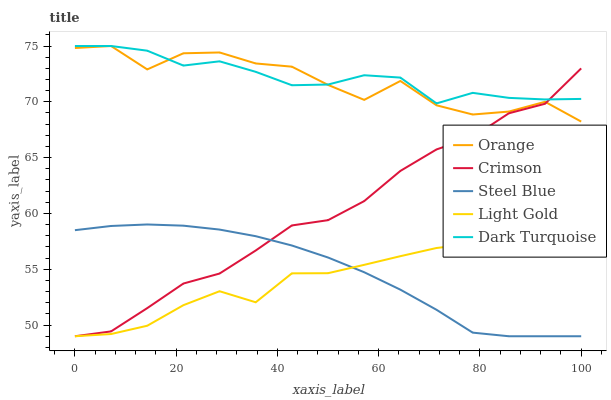Does Light Gold have the minimum area under the curve?
Answer yes or no. Yes. Does Dark Turquoise have the maximum area under the curve?
Answer yes or no. Yes. Does Crimson have the minimum area under the curve?
Answer yes or no. No. Does Crimson have the maximum area under the curve?
Answer yes or no. No. Is Steel Blue the smoothest?
Answer yes or no. Yes. Is Orange the roughest?
Answer yes or no. Yes. Is Crimson the smoothest?
Answer yes or no. No. Is Crimson the roughest?
Answer yes or no. No. Does Crimson have the lowest value?
Answer yes or no. Yes. Does Dark Turquoise have the lowest value?
Answer yes or no. No. Does Dark Turquoise have the highest value?
Answer yes or no. Yes. Does Crimson have the highest value?
Answer yes or no. No. Is Steel Blue less than Orange?
Answer yes or no. Yes. Is Orange greater than Light Gold?
Answer yes or no. Yes. Does Dark Turquoise intersect Orange?
Answer yes or no. Yes. Is Dark Turquoise less than Orange?
Answer yes or no. No. Is Dark Turquoise greater than Orange?
Answer yes or no. No. Does Steel Blue intersect Orange?
Answer yes or no. No. 